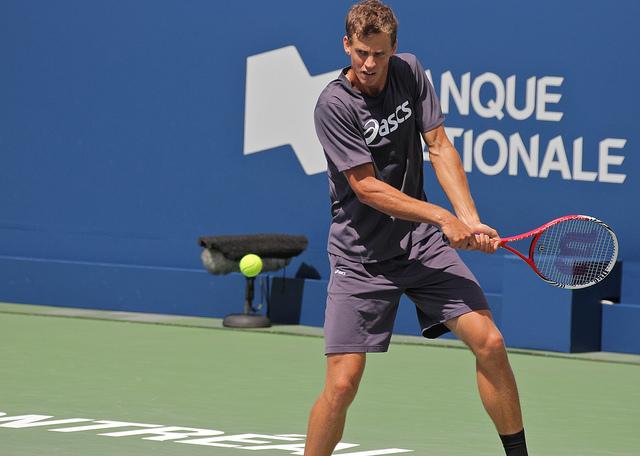What color is the ball?
Short answer required. Yellow. Is this match sponsored by J.P. Morgan?
Keep it brief. No. What game is the man playing?
Give a very brief answer. Tennis. Is he holding the racket with two hands?
Short answer required. Yes. What color shorts is he wearing?
Write a very short answer. Blue. 